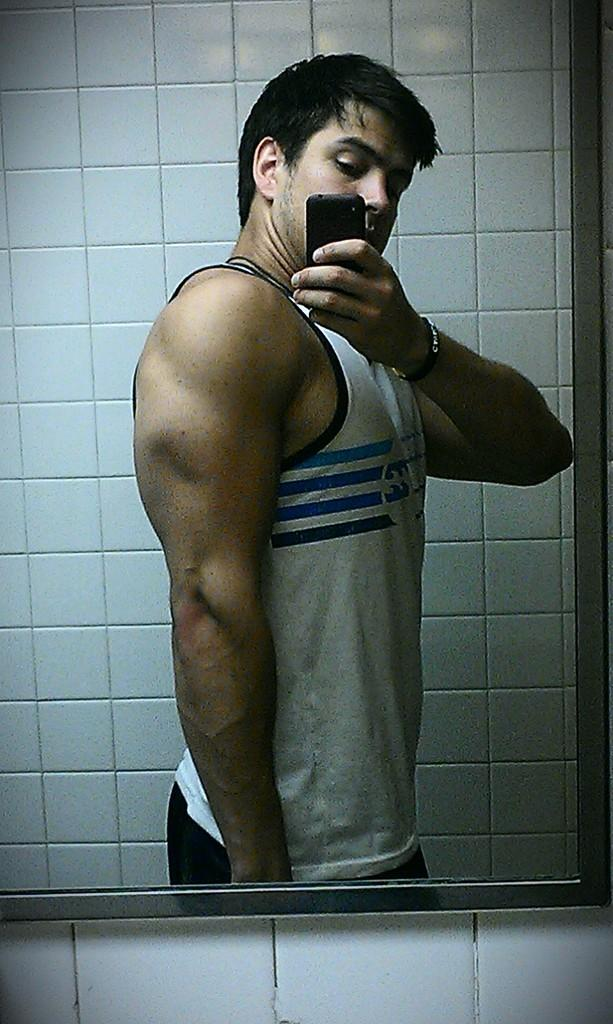What can be seen in the image? There is a person in the image. What else is visible in the image besides the person? The person's reflection is visible in a mirror. What is the person wearing? The person is wearing clothes. What object is the person holding in their hand? The person is holding a phone in their hand. What type of noise can be heard coming from the frame in the image? There is no frame present in the image, and therefore no noise can be heard coming from it. 